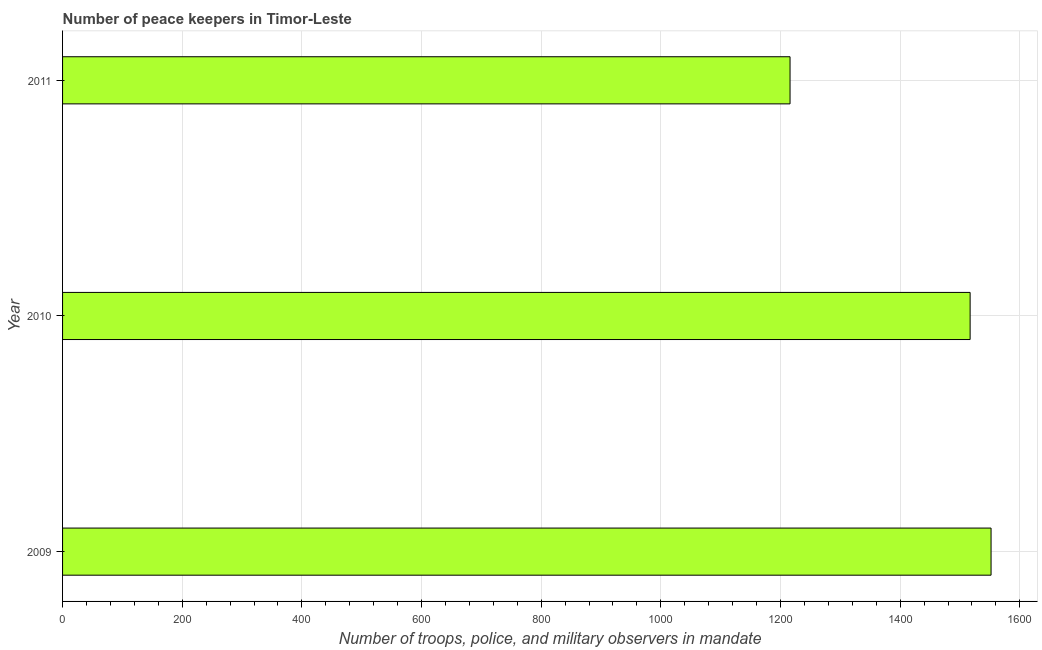Does the graph contain grids?
Give a very brief answer. Yes. What is the title of the graph?
Keep it short and to the point. Number of peace keepers in Timor-Leste. What is the label or title of the X-axis?
Ensure brevity in your answer.  Number of troops, police, and military observers in mandate. What is the number of peace keepers in 2010?
Keep it short and to the point. 1517. Across all years, what is the maximum number of peace keepers?
Your answer should be very brief. 1552. Across all years, what is the minimum number of peace keepers?
Ensure brevity in your answer.  1216. In which year was the number of peace keepers minimum?
Give a very brief answer. 2011. What is the sum of the number of peace keepers?
Your response must be concise. 4285. What is the difference between the number of peace keepers in 2010 and 2011?
Make the answer very short. 301. What is the average number of peace keepers per year?
Give a very brief answer. 1428. What is the median number of peace keepers?
Keep it short and to the point. 1517. Do a majority of the years between 2011 and 2010 (inclusive) have number of peace keepers greater than 1520 ?
Provide a succinct answer. No. What is the ratio of the number of peace keepers in 2010 to that in 2011?
Ensure brevity in your answer.  1.25. Is the number of peace keepers in 2009 less than that in 2010?
Your response must be concise. No. Is the difference between the number of peace keepers in 2010 and 2011 greater than the difference between any two years?
Keep it short and to the point. No. What is the difference between the highest and the lowest number of peace keepers?
Give a very brief answer. 336. How many bars are there?
Your answer should be very brief. 3. What is the difference between two consecutive major ticks on the X-axis?
Keep it short and to the point. 200. What is the Number of troops, police, and military observers in mandate of 2009?
Your response must be concise. 1552. What is the Number of troops, police, and military observers in mandate in 2010?
Your answer should be very brief. 1517. What is the Number of troops, police, and military observers in mandate of 2011?
Give a very brief answer. 1216. What is the difference between the Number of troops, police, and military observers in mandate in 2009 and 2011?
Offer a very short reply. 336. What is the difference between the Number of troops, police, and military observers in mandate in 2010 and 2011?
Your answer should be compact. 301. What is the ratio of the Number of troops, police, and military observers in mandate in 2009 to that in 2010?
Your answer should be very brief. 1.02. What is the ratio of the Number of troops, police, and military observers in mandate in 2009 to that in 2011?
Give a very brief answer. 1.28. What is the ratio of the Number of troops, police, and military observers in mandate in 2010 to that in 2011?
Your answer should be very brief. 1.25. 